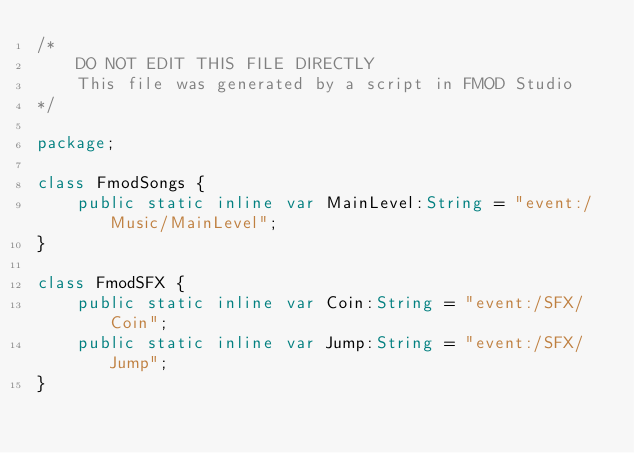Convert code to text. <code><loc_0><loc_0><loc_500><loc_500><_Haxe_>/*
    DO NOT EDIT THIS FILE DIRECTLY
    This file was generated by a script in FMOD Studio 
*/

package;

class FmodSongs {
    public static inline var MainLevel:String = "event:/Music/MainLevel";
}

class FmodSFX {
    public static inline var Coin:String = "event:/SFX/Coin";
    public static inline var Jump:String = "event:/SFX/Jump";
}
</code> 